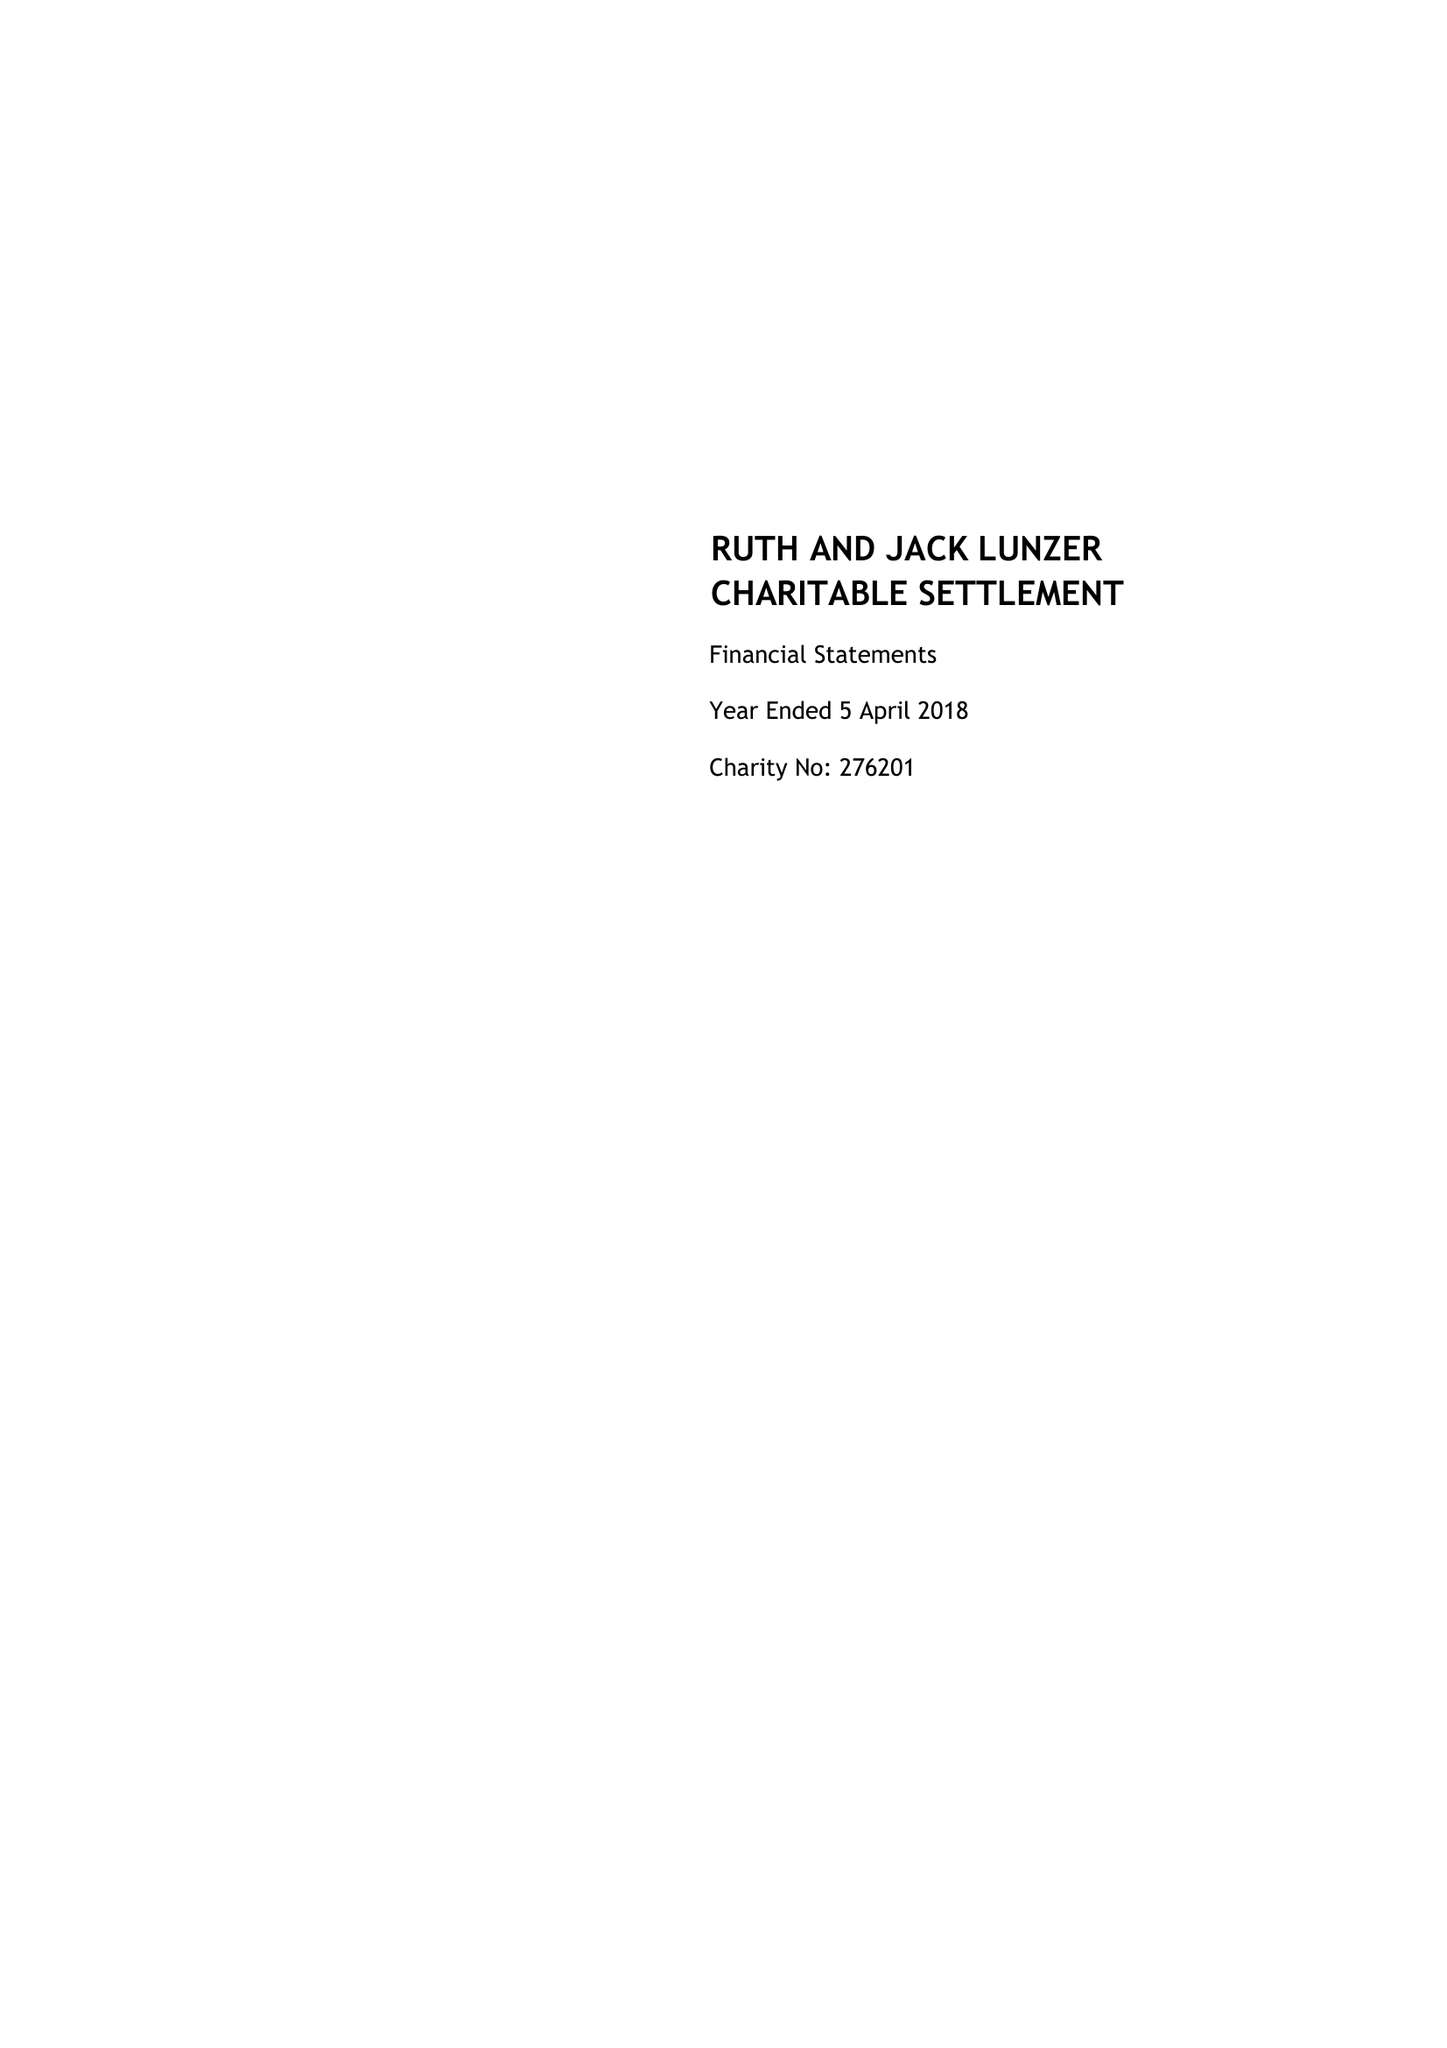What is the value for the address__post_town?
Answer the question using a single word or phrase. LONDON 